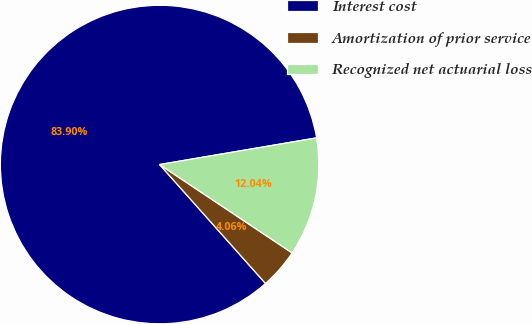Convert chart to OTSL. <chart><loc_0><loc_0><loc_500><loc_500><pie_chart><fcel>Interest cost<fcel>Amortization of prior service<fcel>Recognized net actuarial loss<nl><fcel>83.9%<fcel>4.06%<fcel>12.04%<nl></chart> 